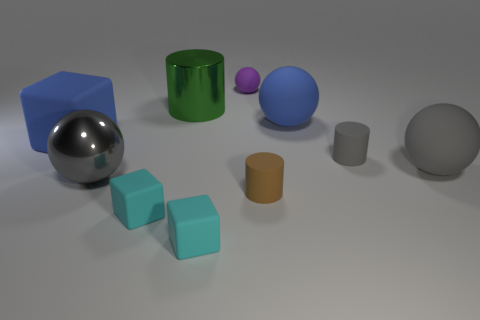Subtract all green cylinders. How many cylinders are left? 2 Subtract all tiny matte cylinders. How many cylinders are left? 1 Subtract all large gray metal balls. Subtract all tiny blue cubes. How many objects are left? 9 Add 9 tiny purple rubber spheres. How many tiny purple rubber spheres are left? 10 Add 7 brown rubber objects. How many brown rubber objects exist? 8 Subtract 1 cyan cubes. How many objects are left? 9 Subtract all cylinders. How many objects are left? 7 Subtract 1 cubes. How many cubes are left? 2 Subtract all red cylinders. Subtract all cyan balls. How many cylinders are left? 3 Subtract all yellow spheres. How many brown cylinders are left? 1 